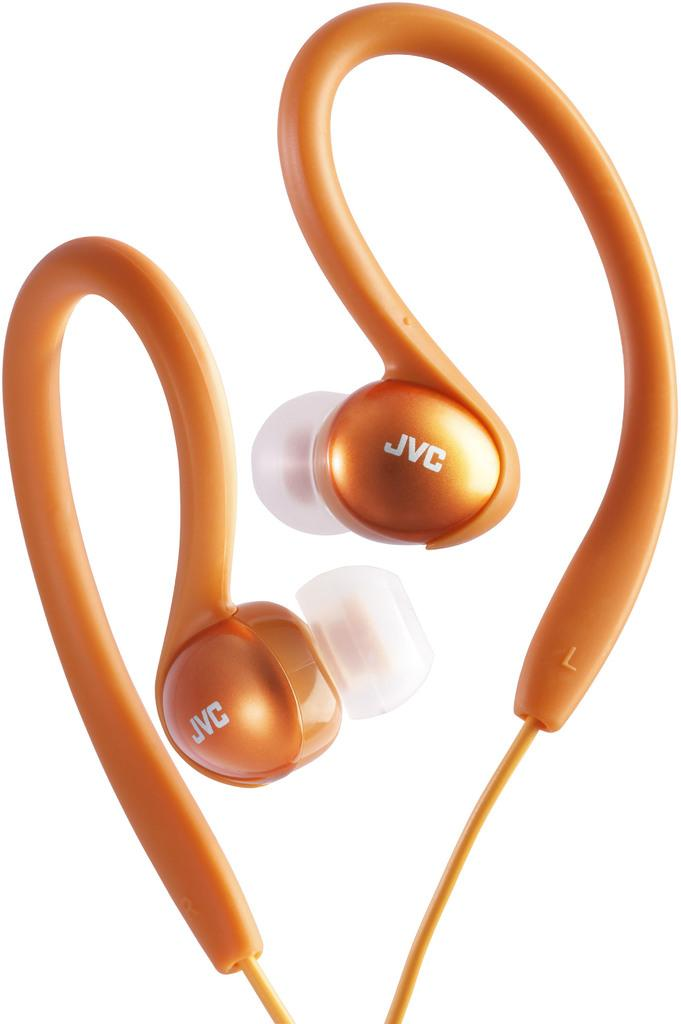<image>
Summarize the visual content of the image. An orange pair of earbuds says JVC on it. 